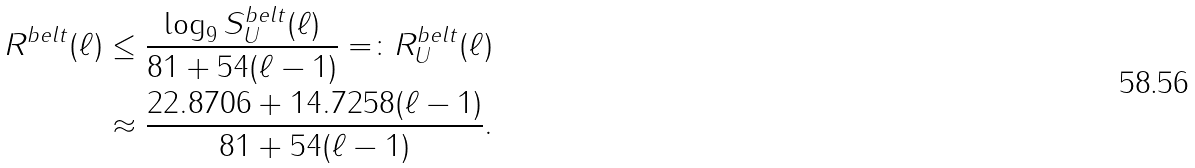<formula> <loc_0><loc_0><loc_500><loc_500>R ^ { b e l t } ( \ell ) & \leq \frac { \log _ { 9 } S _ { U } ^ { b e l t } ( \ell ) } { 8 1 + 5 4 ( \ell - 1 ) } = \colon R _ { U } ^ { b e l t } ( \ell ) \\ & \approx \frac { 2 2 . 8 7 0 6 + 1 4 . 7 2 5 8 ( \ell - 1 ) } { 8 1 + 5 4 ( \ell - 1 ) } .</formula> 